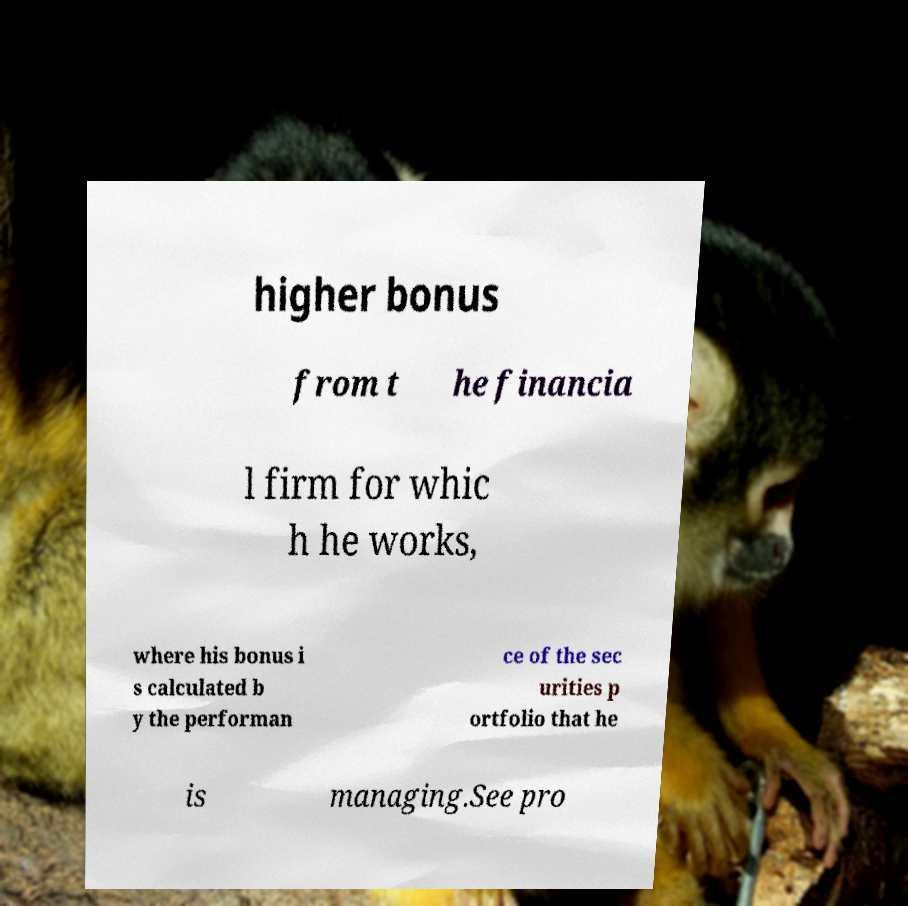Could you extract and type out the text from this image? higher bonus from t he financia l firm for whic h he works, where his bonus i s calculated b y the performan ce of the sec urities p ortfolio that he is managing.See pro 